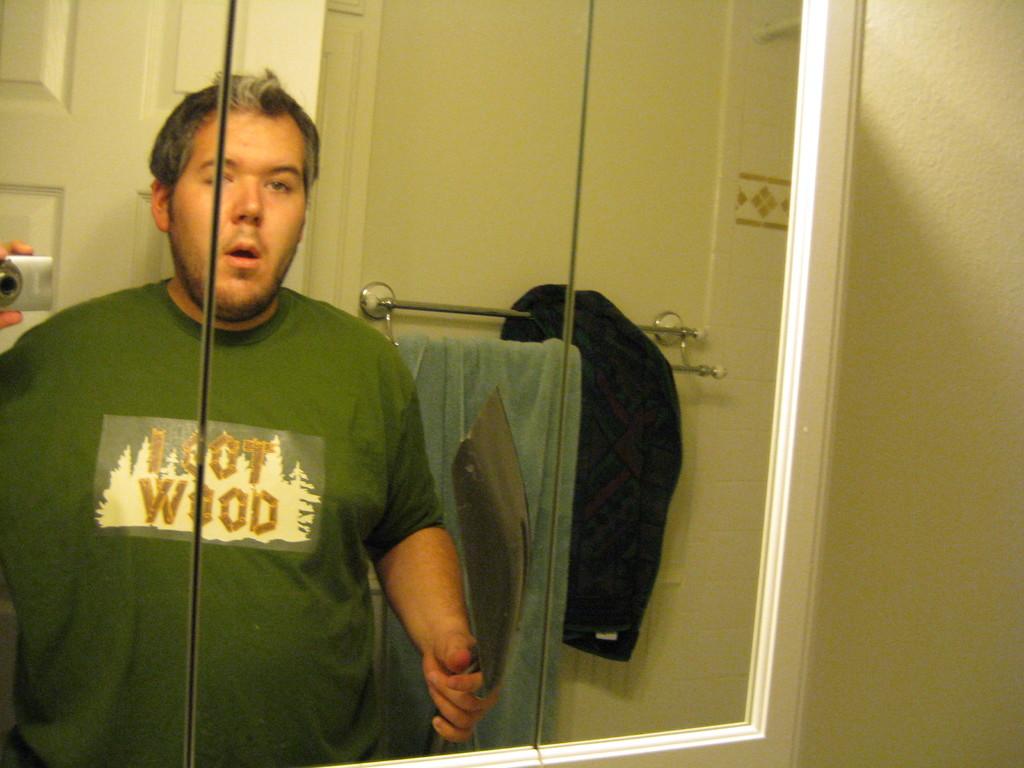What does the man's shirt say?
Give a very brief answer. I got wood. 